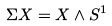<formula> <loc_0><loc_0><loc_500><loc_500>\Sigma X = X \wedge S ^ { 1 }</formula> 